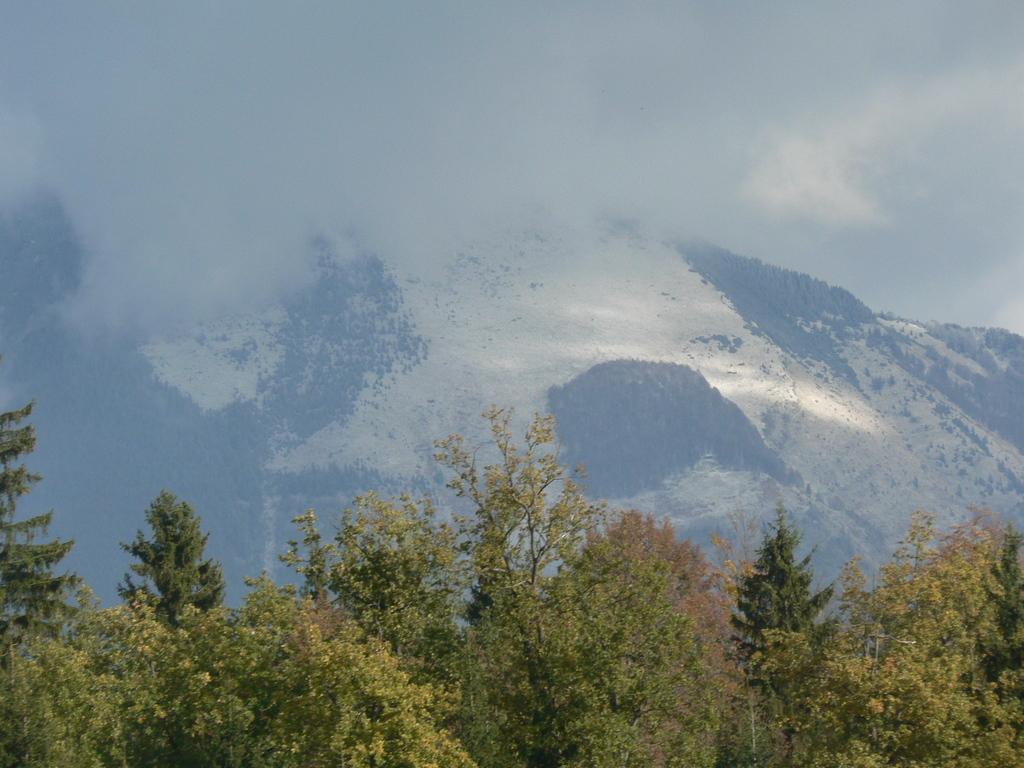Could you give a brief overview of what you see in this image? There are trees, mountains and fog. 